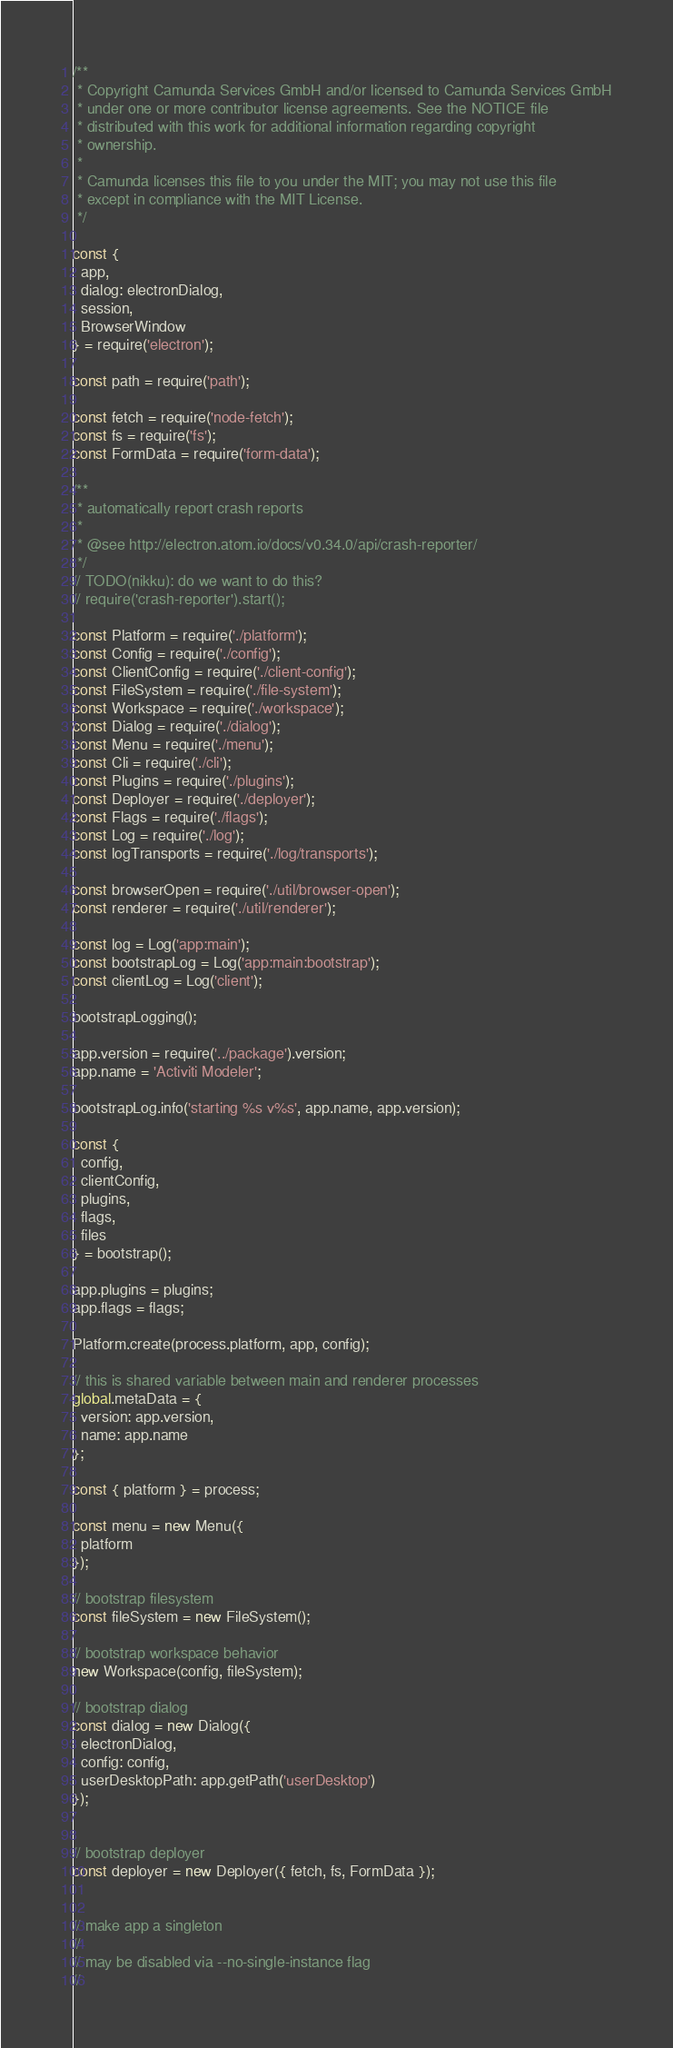<code> <loc_0><loc_0><loc_500><loc_500><_JavaScript_>/**
 * Copyright Camunda Services GmbH and/or licensed to Camunda Services GmbH
 * under one or more contributor license agreements. See the NOTICE file
 * distributed with this work for additional information regarding copyright
 * ownership.
 *
 * Camunda licenses this file to you under the MIT; you may not use this file
 * except in compliance with the MIT License.
 */

const {
  app,
  dialog: electronDialog,
  session,
  BrowserWindow
} = require('electron');

const path = require('path');

const fetch = require('node-fetch');
const fs = require('fs');
const FormData = require('form-data');

/**
 * automatically report crash reports
 *
 * @see http://electron.atom.io/docs/v0.34.0/api/crash-reporter/
 */
// TODO(nikku): do we want to do this?
// require('crash-reporter').start();

const Platform = require('./platform');
const Config = require('./config');
const ClientConfig = require('./client-config');
const FileSystem = require('./file-system');
const Workspace = require('./workspace');
const Dialog = require('./dialog');
const Menu = require('./menu');
const Cli = require('./cli');
const Plugins = require('./plugins');
const Deployer = require('./deployer');
const Flags = require('./flags');
const Log = require('./log');
const logTransports = require('./log/transports');

const browserOpen = require('./util/browser-open');
const renderer = require('./util/renderer');

const log = Log('app:main');
const bootstrapLog = Log('app:main:bootstrap');
const clientLog = Log('client');

bootstrapLogging();

app.version = require('../package').version;
app.name = 'Activiti Modeler';

bootstrapLog.info('starting %s v%s', app.name, app.version);

const {
  config,
  clientConfig,
  plugins,
  flags,
  files
} = bootstrap();

app.plugins = plugins;
app.flags = flags;

Platform.create(process.platform, app, config);

// this is shared variable between main and renderer processes
global.metaData = {
  version: app.version,
  name: app.name
};

const { platform } = process;

const menu = new Menu({
  platform
});

// bootstrap filesystem
const fileSystem = new FileSystem();

// bootstrap workspace behavior
new Workspace(config, fileSystem);

// bootstrap dialog
const dialog = new Dialog({
  electronDialog,
  config: config,
  userDesktopPath: app.getPath('userDesktop')
});


// bootstrap deployer
const deployer = new Deployer({ fetch, fs, FormData });


// make app a singleton
//
// may be disabled via --no-single-instance flag
//</code> 